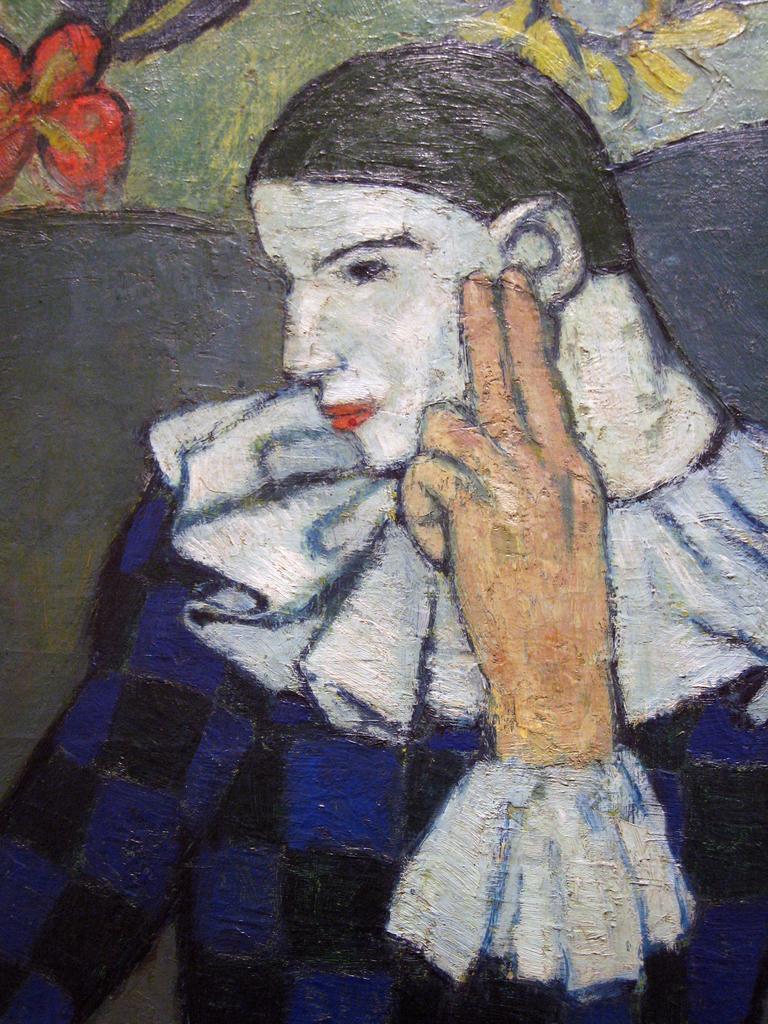Please provide a concise description of this image. In this picture we can see a painting of a person. 